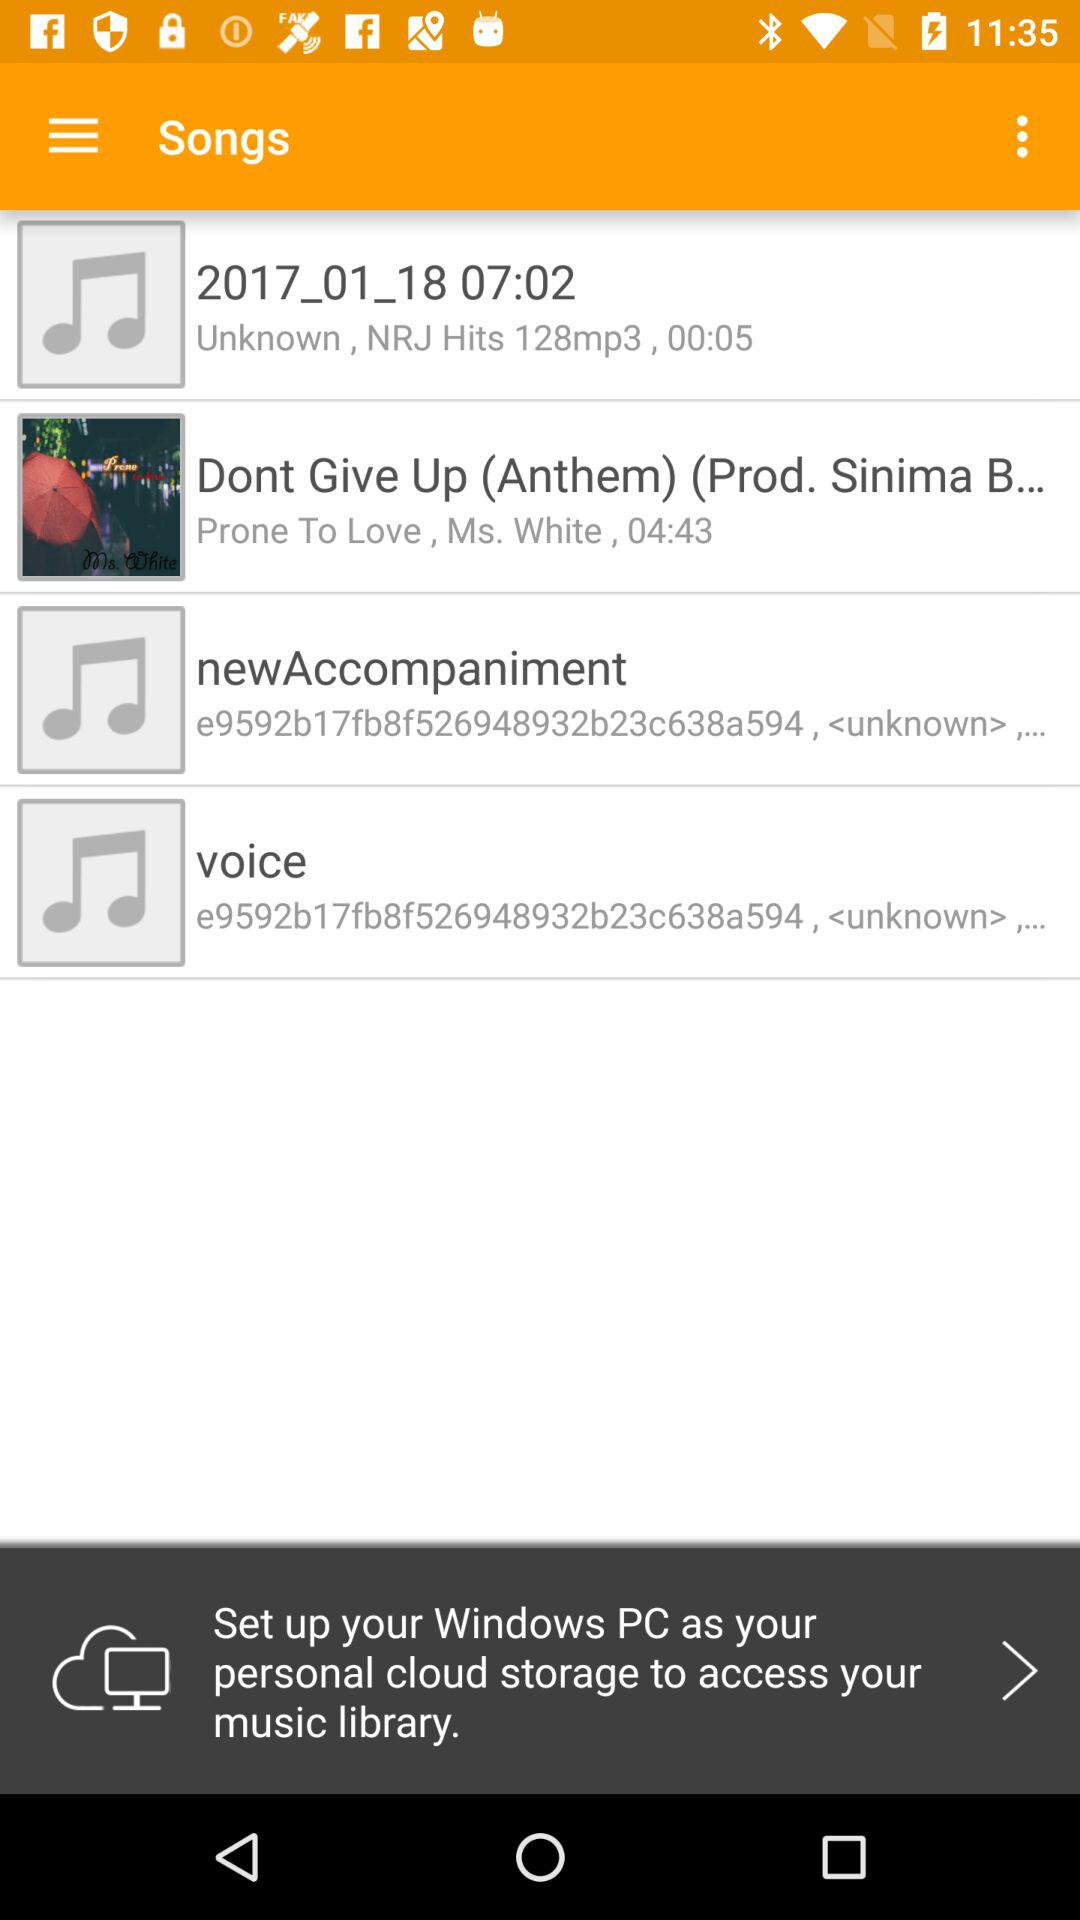What is the duration of "Dont Give Up (Anthem)"? The duration of "Dont Give Up (Anthem)" is 4 minutes 43 seconds. 